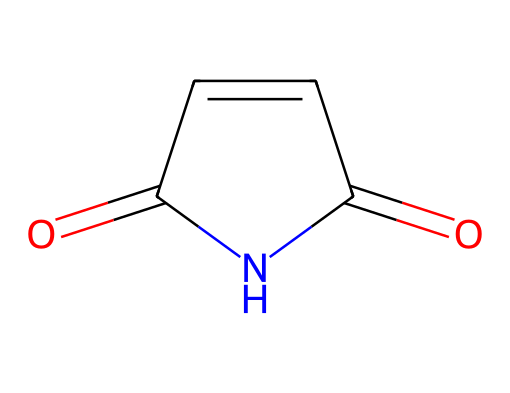What is the molecular formula of maleimide? The SMILES representation can be translated to determine the atoms present. Counting the carbon (C), nitrogen (N), and oxygen (O) atoms gives a total of 4 carbons, 1 nitrogen, and 2 oxygens, resulting in the molecular formula C4H3N1O2.
Answer: C4H3N1O2 How many double bonds are present in maleimide? By examining the SMILES representation, we can see that there are two double bonds: one between a carbon and an oxygen, and one between two carbons in a ring structure. Therefore, there are 2 double bonds in total.
Answer: 2 Is maleimide a cyclic compound? The structure contains a ring part as indicated by the "C1" in the SMILES, which denotes the beginning of a cyclic structure and matches up with "N1" for closure. Hence, maleimide is indeed a cyclic compound.
Answer: Yes Which functional groups are present in maleimide? The structure indicates the presence of a carbonyl (C=O) and an imide (C(=O)N) functional group, based on the connections and arrangement of the atoms in the chemical representation.
Answer: carbonyl and imide What type of reactions can maleimide undergo? Given its reactive imide functional group, maleimide can participate in Michael addition reactions, especially with nucleophiles, due to the electrophilic nature of the double bond adjacent to the imide.
Answer: Michael addition reactions What is the significance of maleimide in bioconjugation techniques? Maleimide is significant in bioconjugation techniques because its reactive double bond allows for the specific labeling of proteins through covalent bond formation with thiols, making it beneficial for various biochemical applications.
Answer: protein labeling 